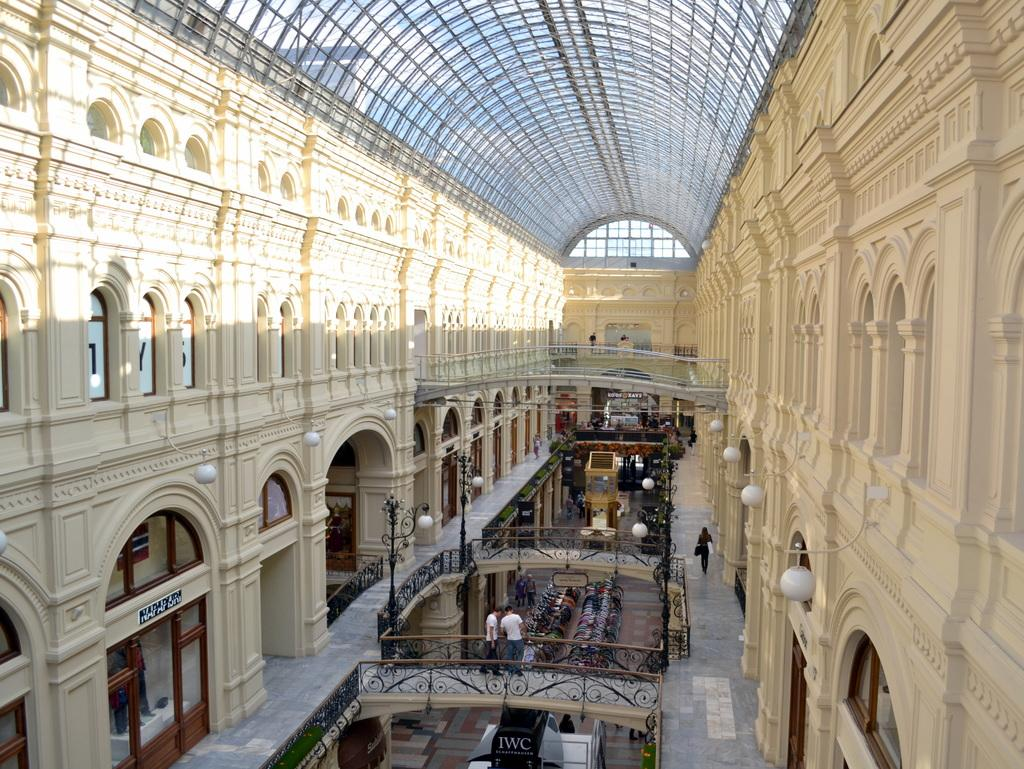What type of structures can be seen in the image? There are buildings in the image. What is the purpose of the barrier in the image? There is a fence in the image, which serves as a barrier or boundary. What type of furniture is present in the image? There are chairs in the image. What type of illumination is present in the image? There are lights in the image. Are there any living beings present in the image? Yes, there are people present in the image. Can you tell me how many baby cards are being used by the machine in the image? There is no baby, card, or machine present in the image. 